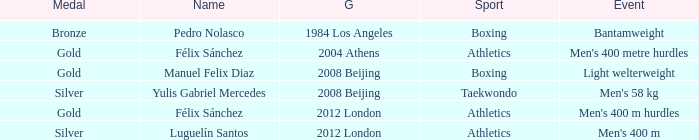What Medal had a Name of manuel felix diaz? Gold. 